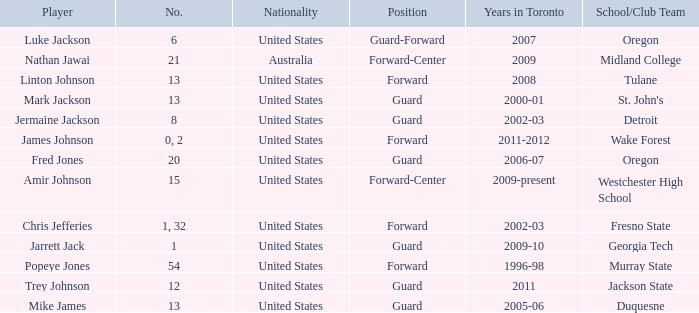What are the total amount of numbers on the Toronto team in 2005-06? 1.0. 